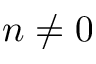Convert formula to latex. <formula><loc_0><loc_0><loc_500><loc_500>n \neq 0</formula> 